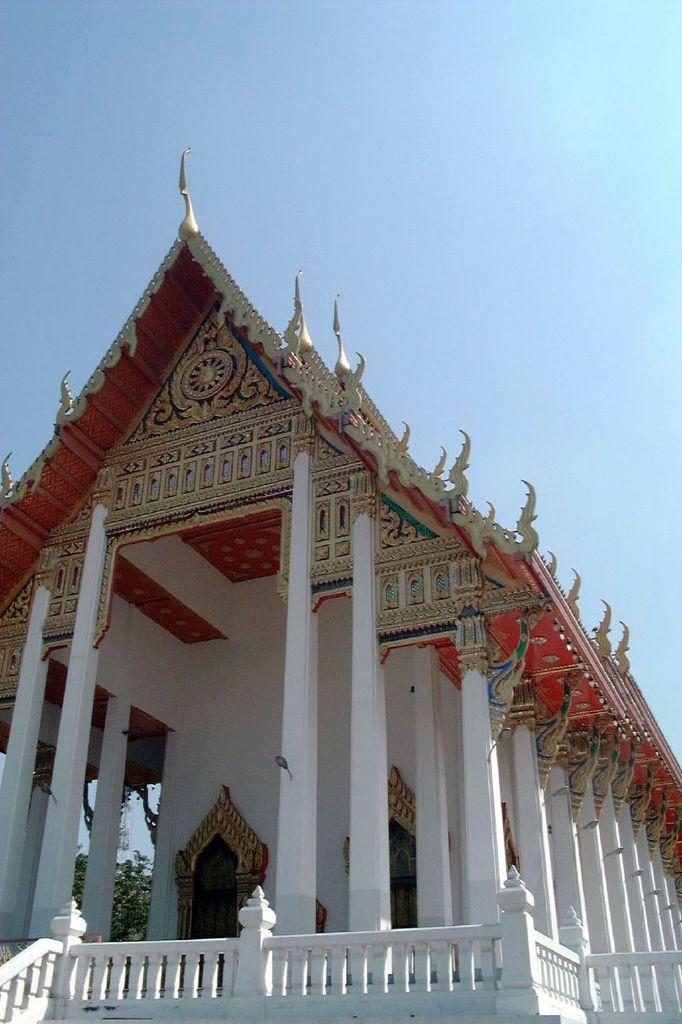Describe this image in one or two sentences. In this image I see a building which is colorful and I see the pillars which are of white in color and in the background I see the sky which is blue in color. 